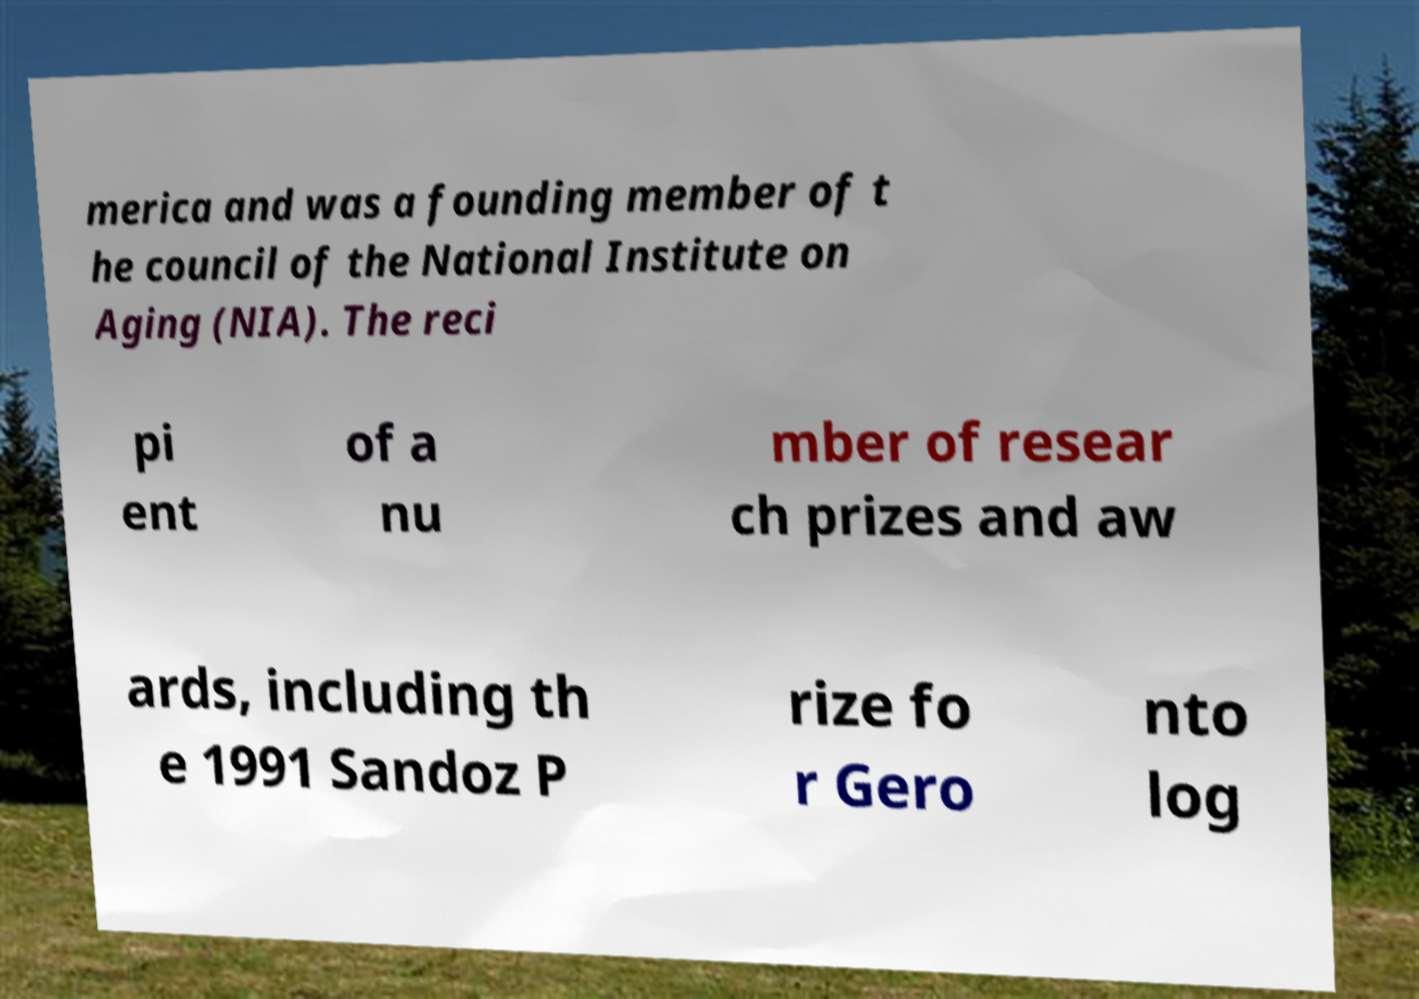There's text embedded in this image that I need extracted. Can you transcribe it verbatim? merica and was a founding member of t he council of the National Institute on Aging (NIA). The reci pi ent of a nu mber of resear ch prizes and aw ards, including th e 1991 Sandoz P rize fo r Gero nto log 